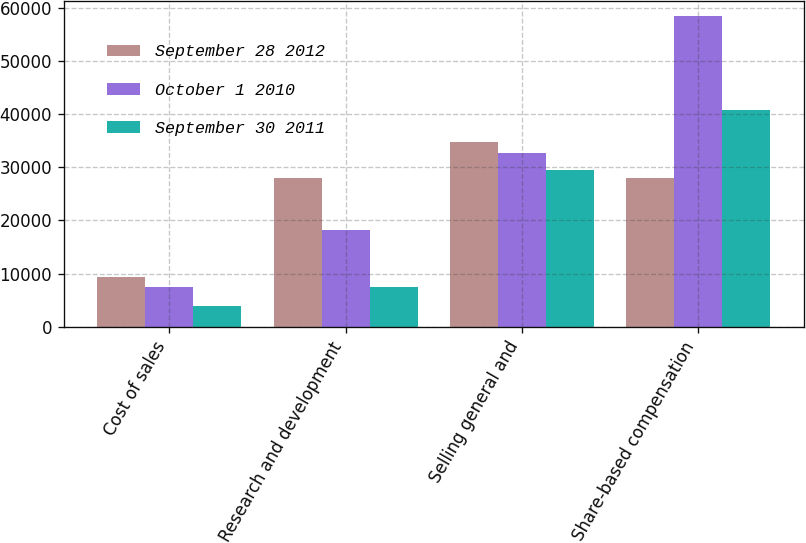Convert chart. <chart><loc_0><loc_0><loc_500><loc_500><stacked_bar_chart><ecel><fcel>Cost of sales<fcel>Research and development<fcel>Selling general and<fcel>Share-based compensation<nl><fcel>September 28 2012<fcel>9419<fcel>27982<fcel>34771<fcel>27982<nl><fcel>October 1 2010<fcel>7557<fcel>18100<fcel>32681<fcel>58338<nl><fcel>September 30 2011<fcel>3857<fcel>7419<fcel>29465<fcel>40741<nl></chart> 